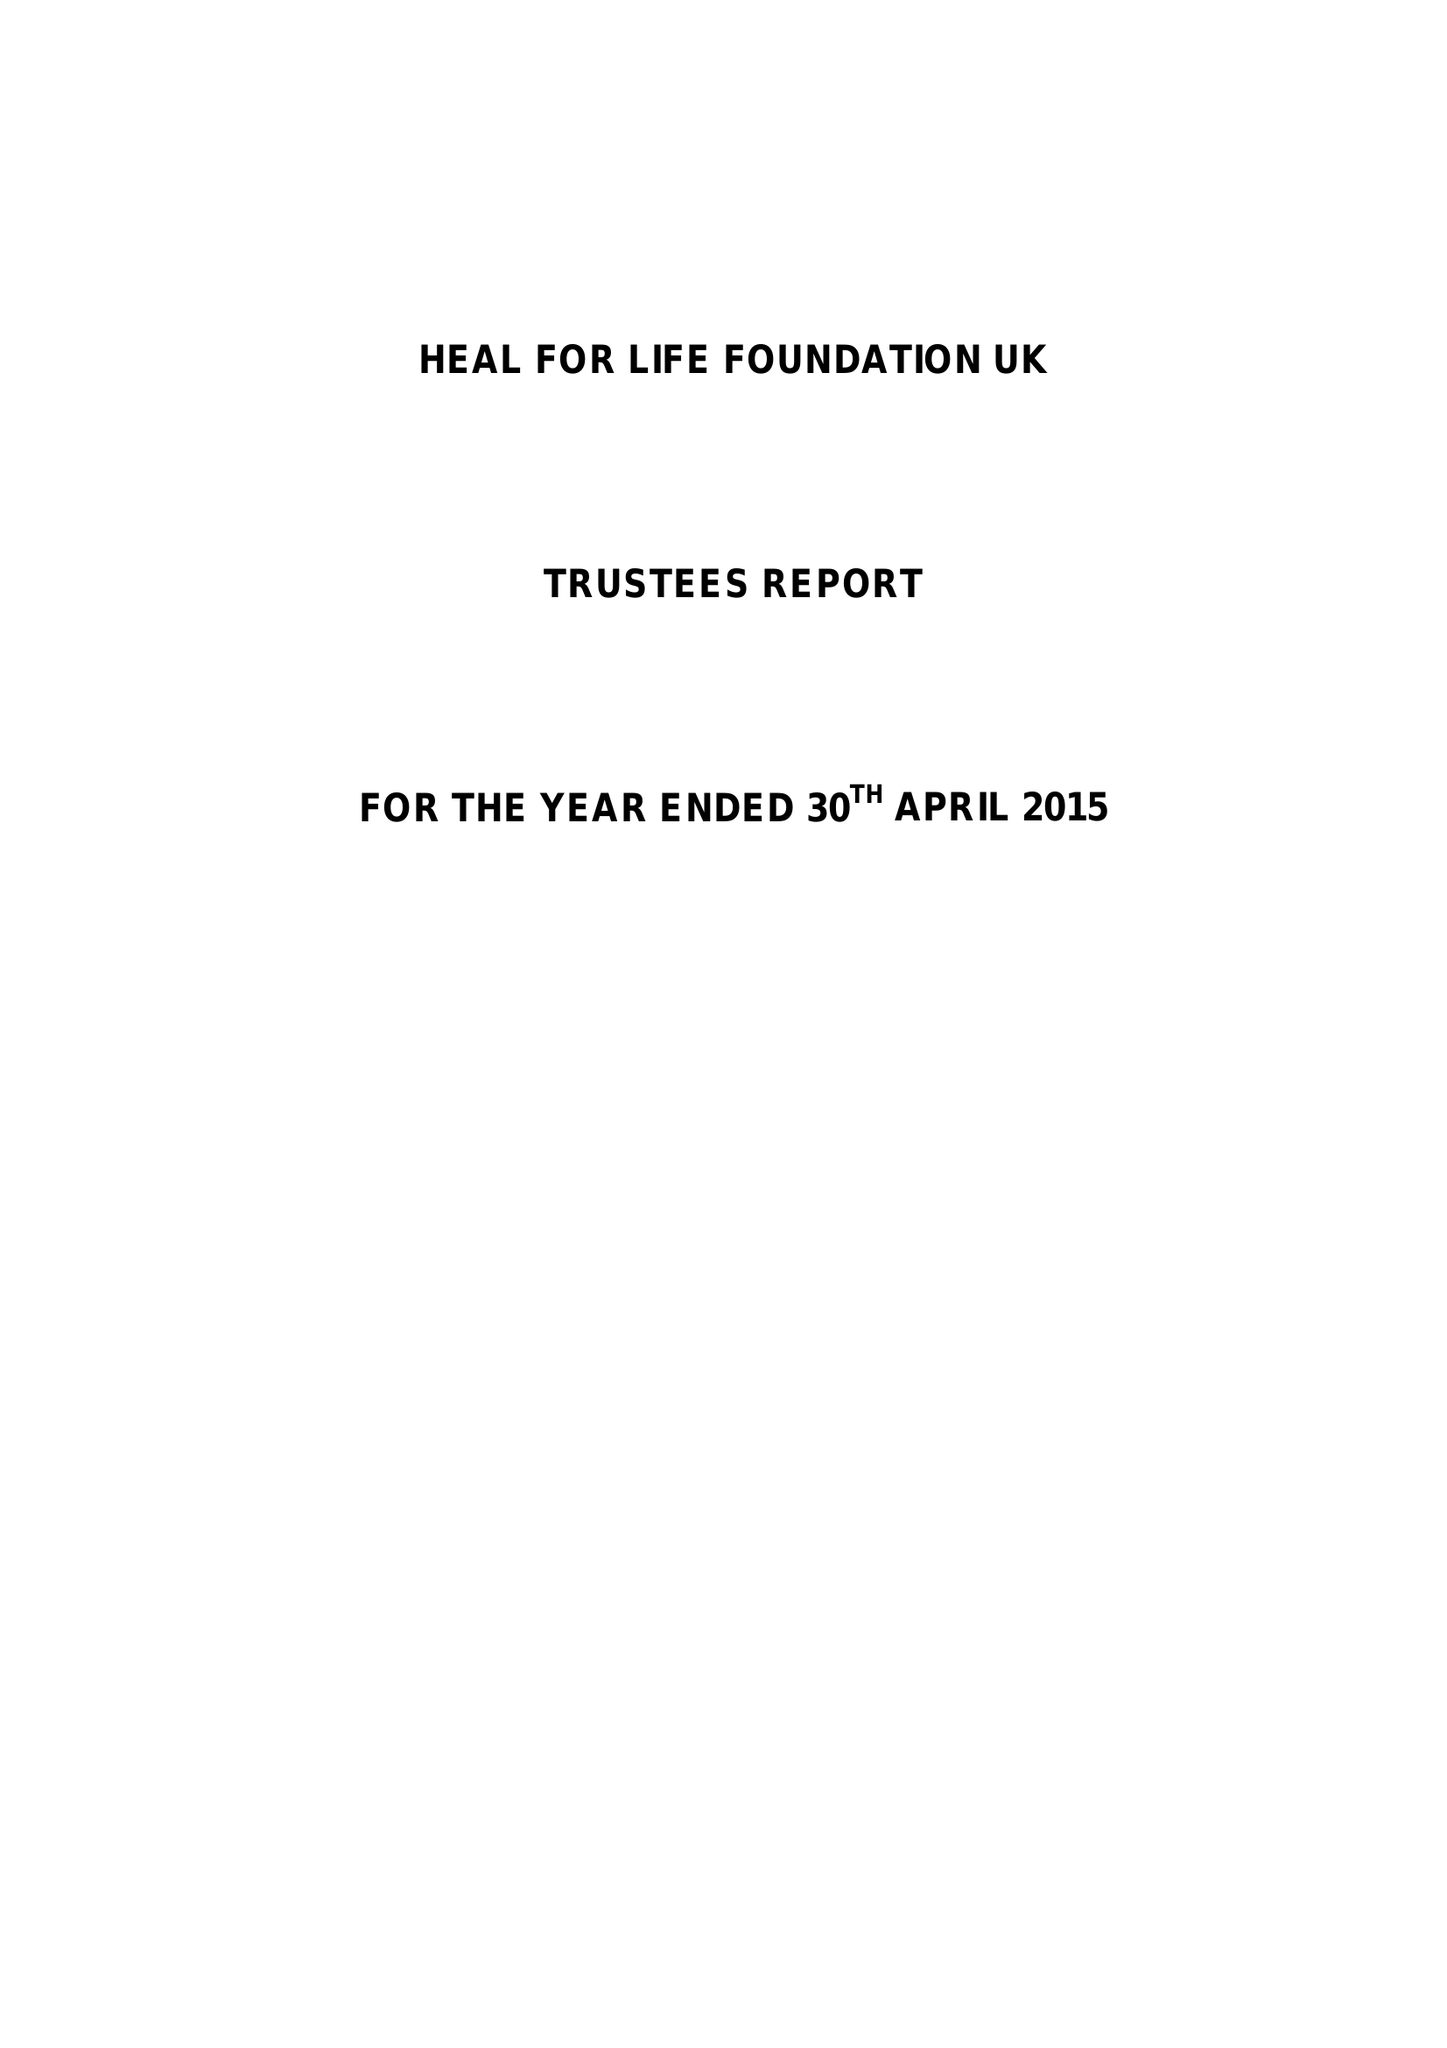What is the value for the report_date?
Answer the question using a single word or phrase. 2015-04-30 